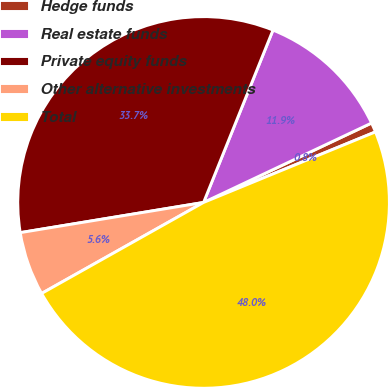Convert chart. <chart><loc_0><loc_0><loc_500><loc_500><pie_chart><fcel>Hedge funds<fcel>Real estate funds<fcel>Private equity funds<fcel>Other alternative investments<fcel>Total<nl><fcel>0.83%<fcel>11.88%<fcel>33.69%<fcel>5.55%<fcel>48.05%<nl></chart> 